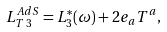<formula> <loc_0><loc_0><loc_500><loc_500>L _ { T \, 3 } ^ { A d S } = L _ { 3 } ^ { * } ( \omega ) + 2 e _ { a } T ^ { a } ,</formula> 